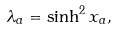Convert formula to latex. <formula><loc_0><loc_0><loc_500><loc_500>\lambda _ { a } = \sinh ^ { 2 } x _ { a } ,</formula> 